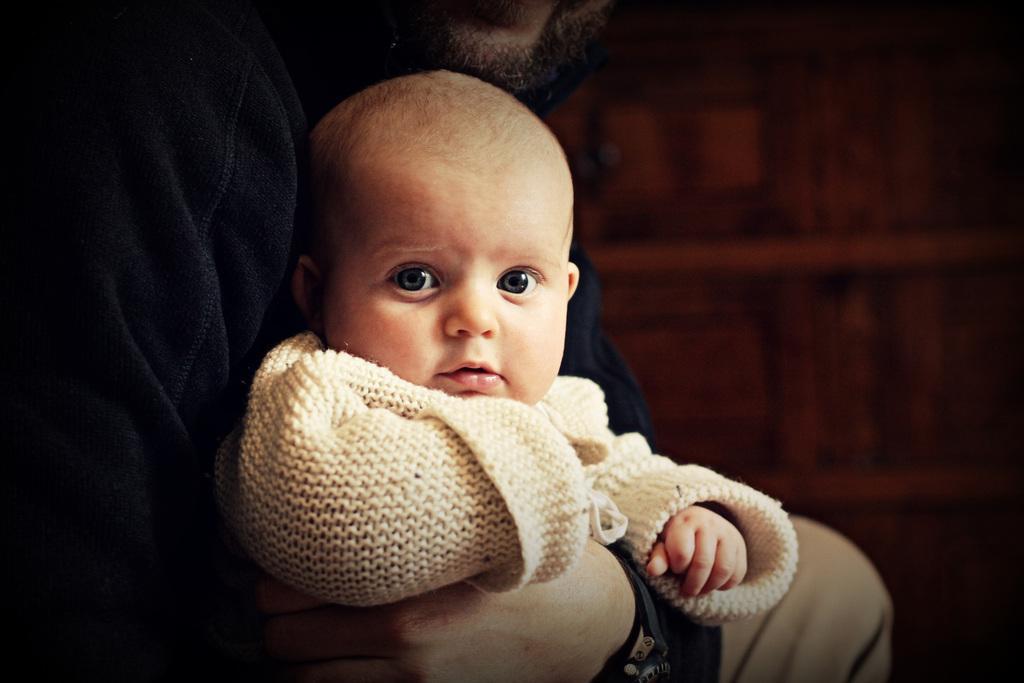Can you describe this image briefly? In this image we can see a kid who is wearing white color dress is held by a person who is wearing black color dress. 